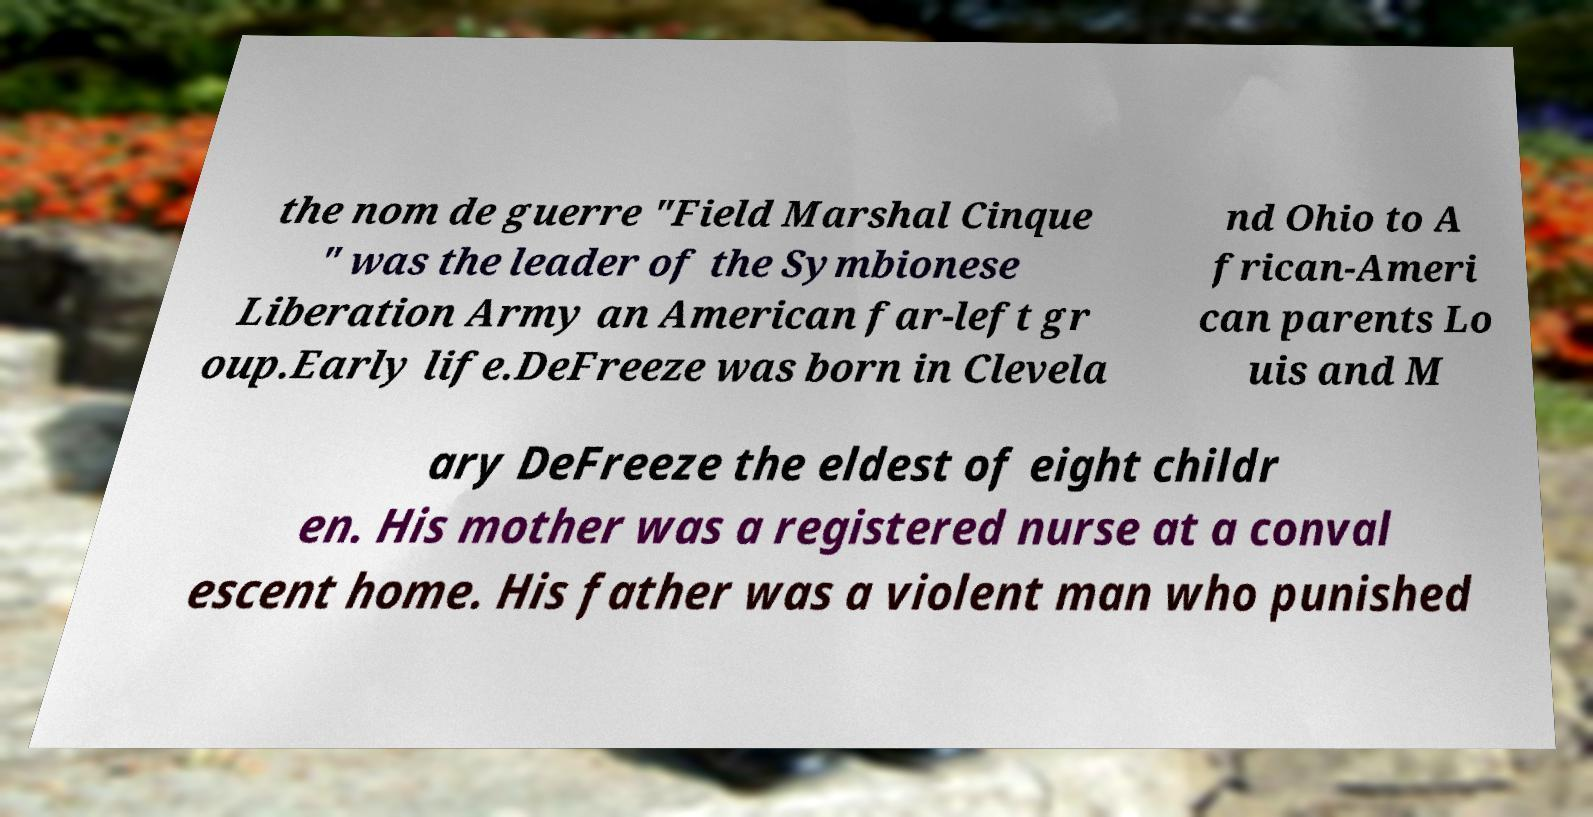Can you read and provide the text displayed in the image?This photo seems to have some interesting text. Can you extract and type it out for me? the nom de guerre "Field Marshal Cinque " was the leader of the Symbionese Liberation Army an American far-left gr oup.Early life.DeFreeze was born in Clevela nd Ohio to A frican-Ameri can parents Lo uis and M ary DeFreeze the eldest of eight childr en. His mother was a registered nurse at a conval escent home. His father was a violent man who punished 